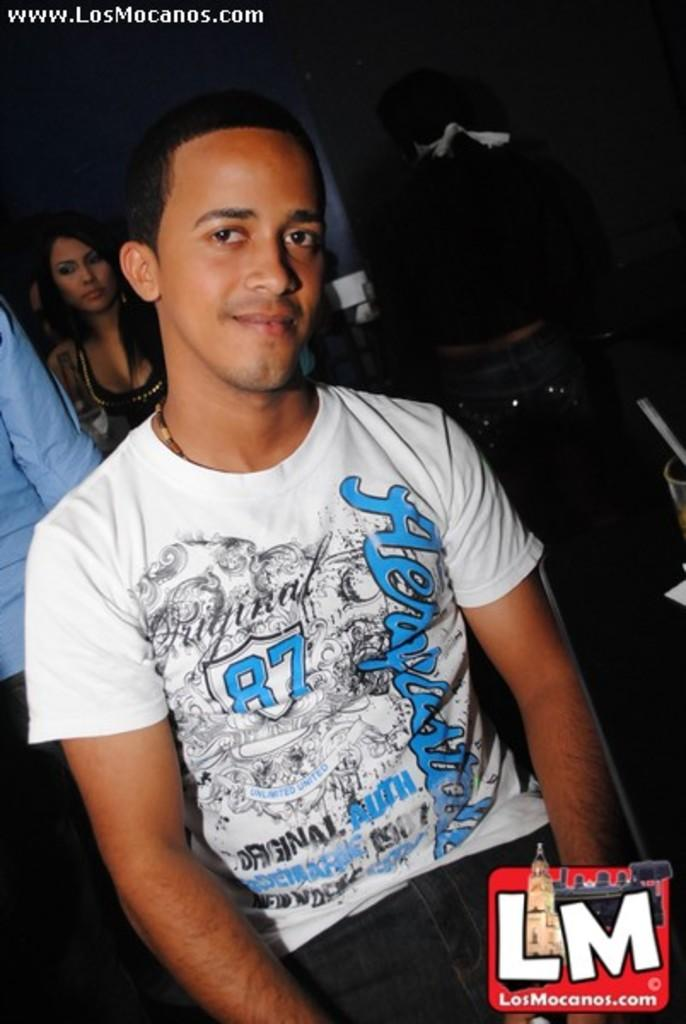Who is the main subject in the foreground of the image? There is a man in the foreground of the image. What can be seen in the background of the image? There are people standing in the background of the image. What type of structure is visible in the image? There is a wall visible in the image. What other objects can be seen in the image? There are other objects present in the image. How many nails can be seen in the image? There is no mention of nails in the provided facts, so we cannot determine if any nails are present in the image. 